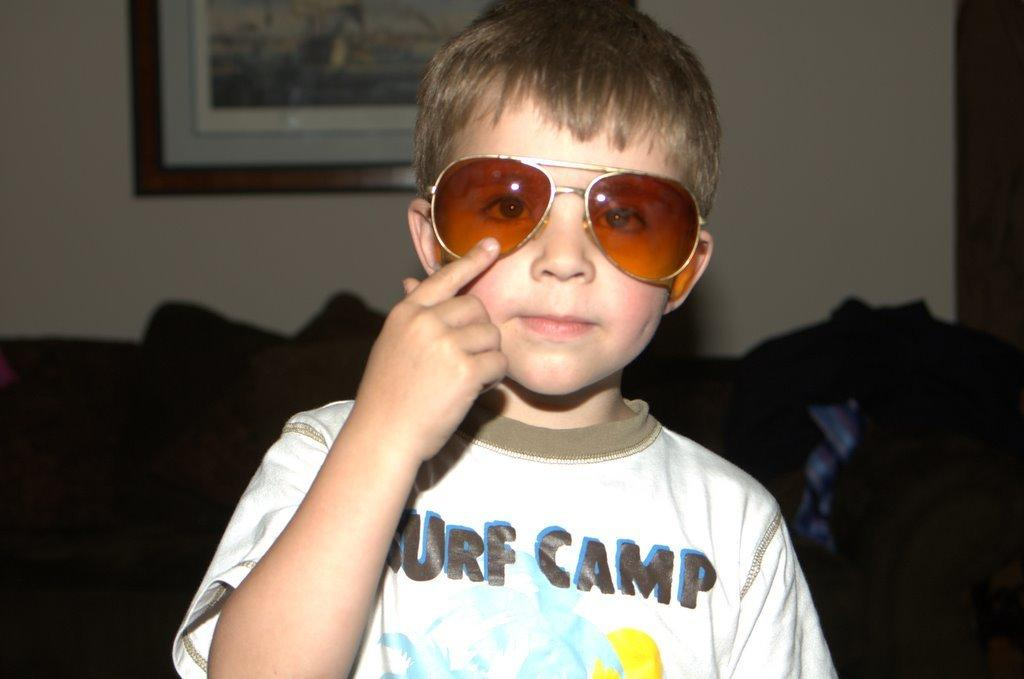Who is the main subject in the image? There is a boy in the image. What is the boy wearing in the image? The boy is wearing sunglasses. What piece of furniture is visible behind the boy? There is a couch behind the boy. What can be seen in the background of the image? There is a wall in the background of the image. What is hanging on the wall in the image? There is a picture frame hanging on the wall. What type of bomb is the boy holding in the image? There is no bomb present in the image; the boy is wearing sunglasses and there are no other objects in his hands. 